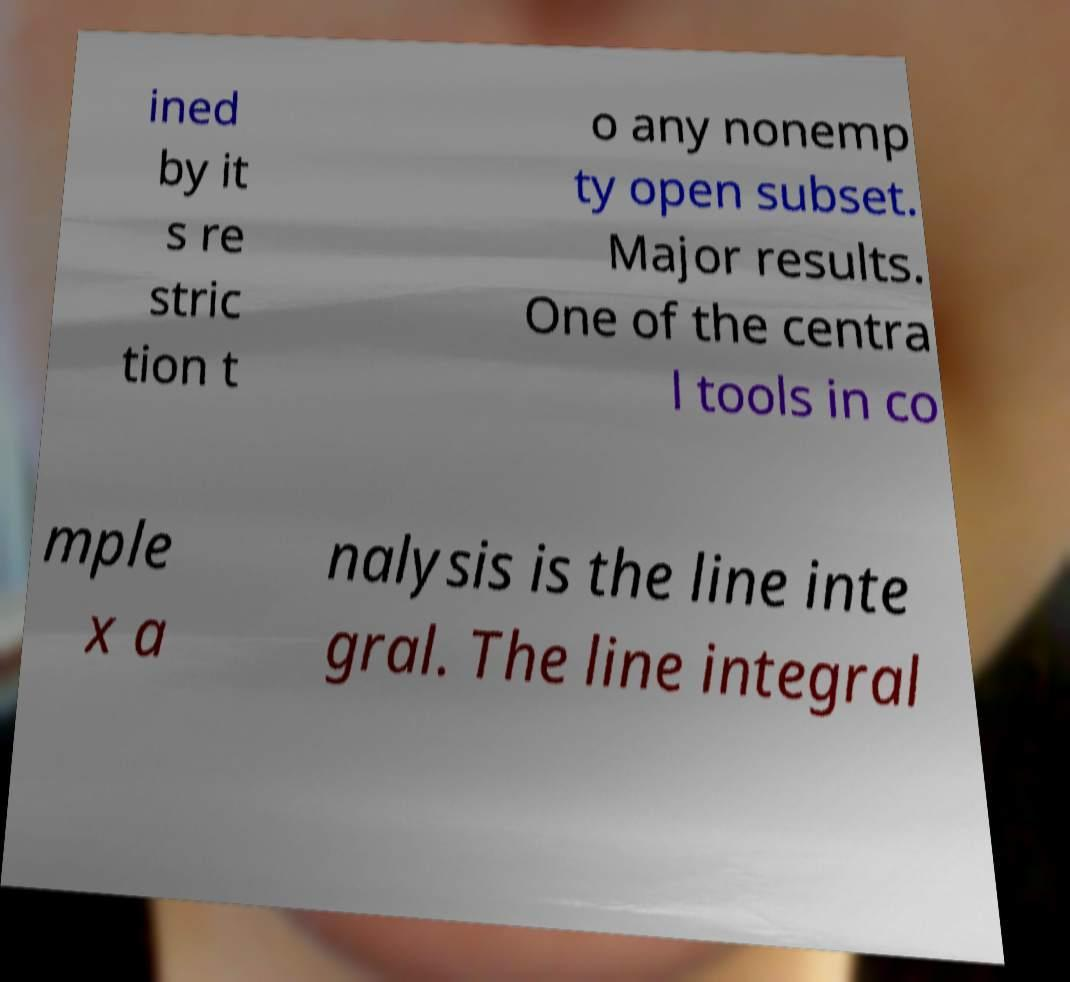I need the written content from this picture converted into text. Can you do that? ined by it s re stric tion t o any nonemp ty open subset. Major results. One of the centra l tools in co mple x a nalysis is the line inte gral. The line integral 